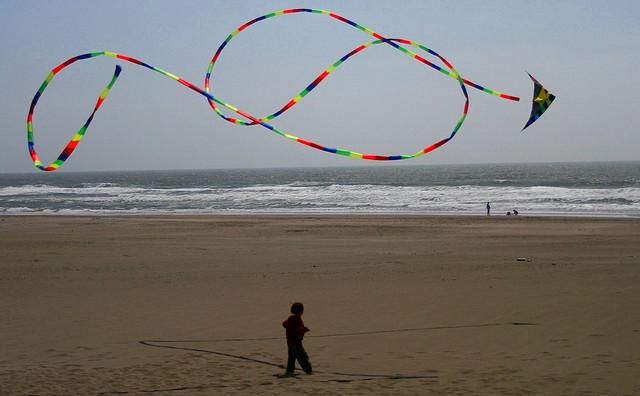What is unique about this kite? Please explain your reasoning. tail. It is very long compared to most 